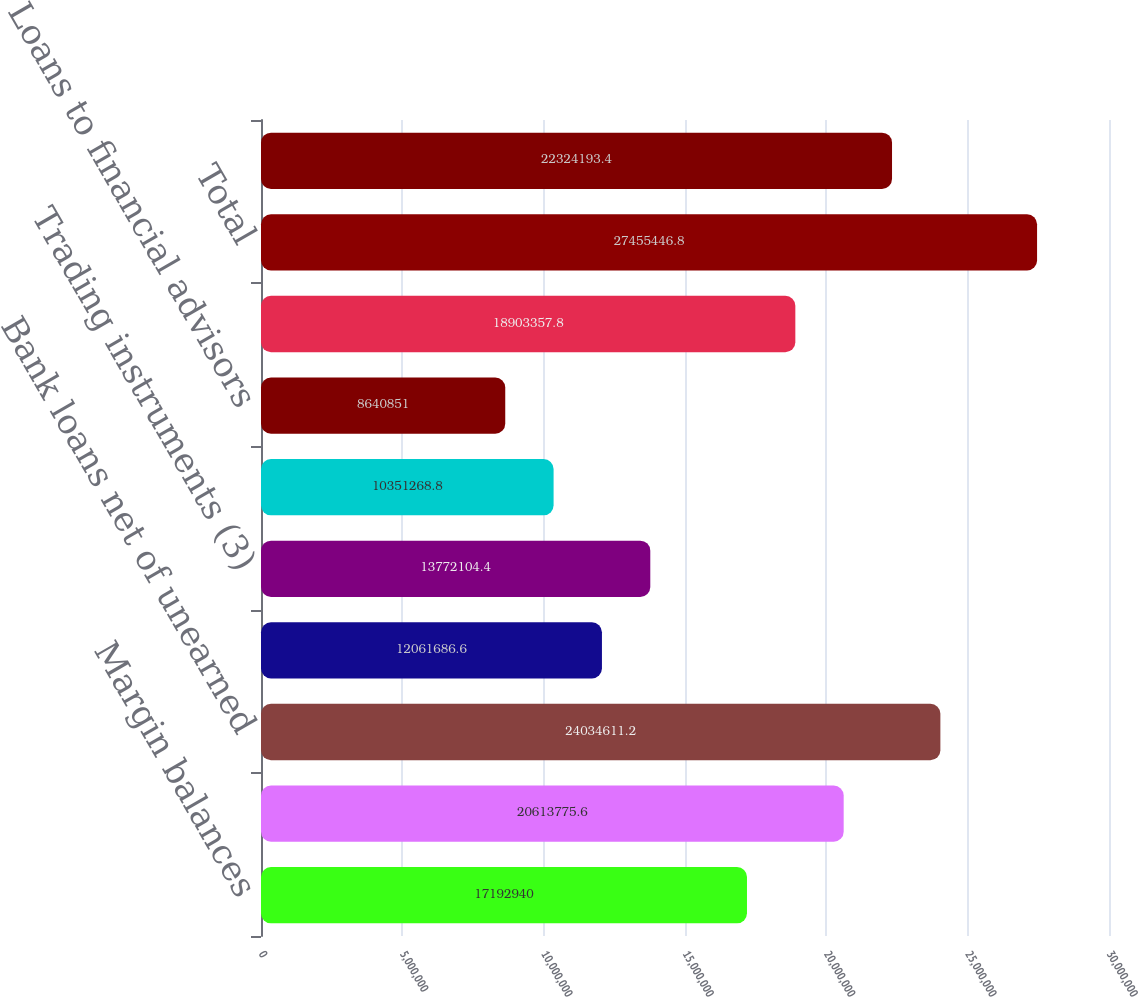Convert chart to OTSL. <chart><loc_0><loc_0><loc_500><loc_500><bar_chart><fcel>Margin balances<fcel>Assets segregated pursuant to<fcel>Bank loans net of unearned<fcel>Available for sale securities<fcel>Trading instruments (3)<fcel>Stock loan<fcel>Loans to financial advisors<fcel>Corporate cash and all other<fcel>Total<fcel>Brokerage client liabilities<nl><fcel>1.71929e+07<fcel>2.06138e+07<fcel>2.40346e+07<fcel>1.20617e+07<fcel>1.37721e+07<fcel>1.03513e+07<fcel>8.64085e+06<fcel>1.89034e+07<fcel>2.74554e+07<fcel>2.23242e+07<nl></chart> 